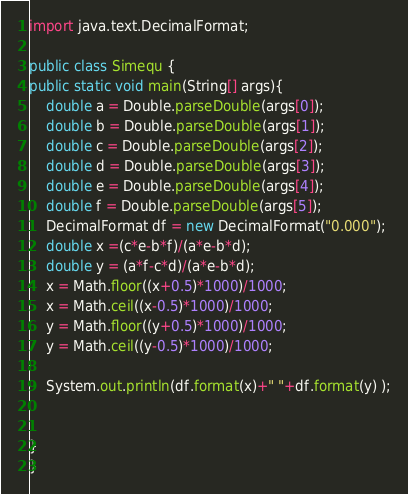<code> <loc_0><loc_0><loc_500><loc_500><_Java_>import java.text.DecimalFormat;

public class Simequ {
public static void main(String[] args){
	double a = Double.parseDouble(args[0]);
	double b = Double.parseDouble(args[1]);
	double c = Double.parseDouble(args[2]);
	double d = Double.parseDouble(args[3]);
	double e = Double.parseDouble(args[4]);
	double f = Double.parseDouble(args[5]);
	DecimalFormat df = new DecimalFormat("0.000");
	double x =(c*e-b*f)/(a*e-b*d);
	double y = (a*f-c*d)/(a*e-b*d);
	x = Math.floor((x+0.5)*1000)/1000;
	x = Math.ceil((x-0.5)*1000)/1000;
	y = Math.floor((y+0.5)*1000)/1000;
	y = Math.ceil((y-0.5)*1000)/1000;

	System.out.println(df.format(x)+" "+df.format(y) );


}
}</code> 